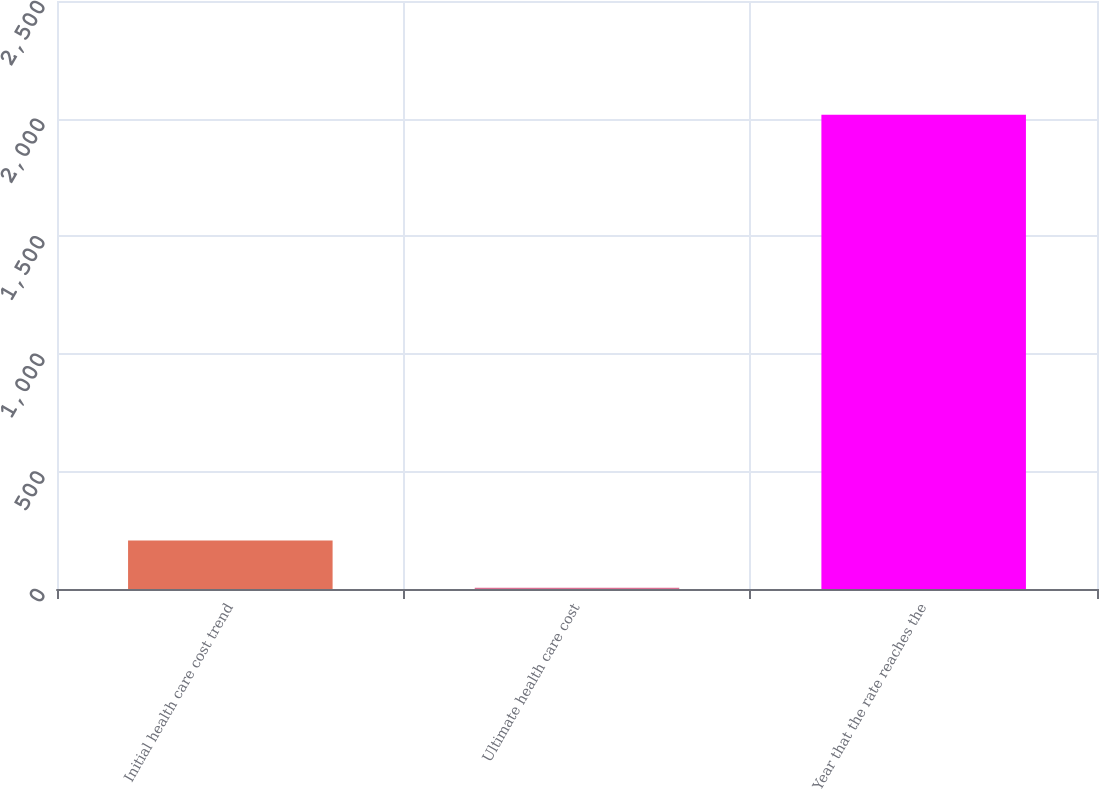Convert chart. <chart><loc_0><loc_0><loc_500><loc_500><bar_chart><fcel>Initial health care cost trend<fcel>Ultimate health care cost<fcel>Year that the rate reaches the<nl><fcel>206.1<fcel>5<fcel>2016<nl></chart> 